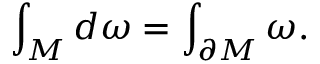<formula> <loc_0><loc_0><loc_500><loc_500>\int _ { M } d \omega = \int _ { \partial M } \omega .</formula> 